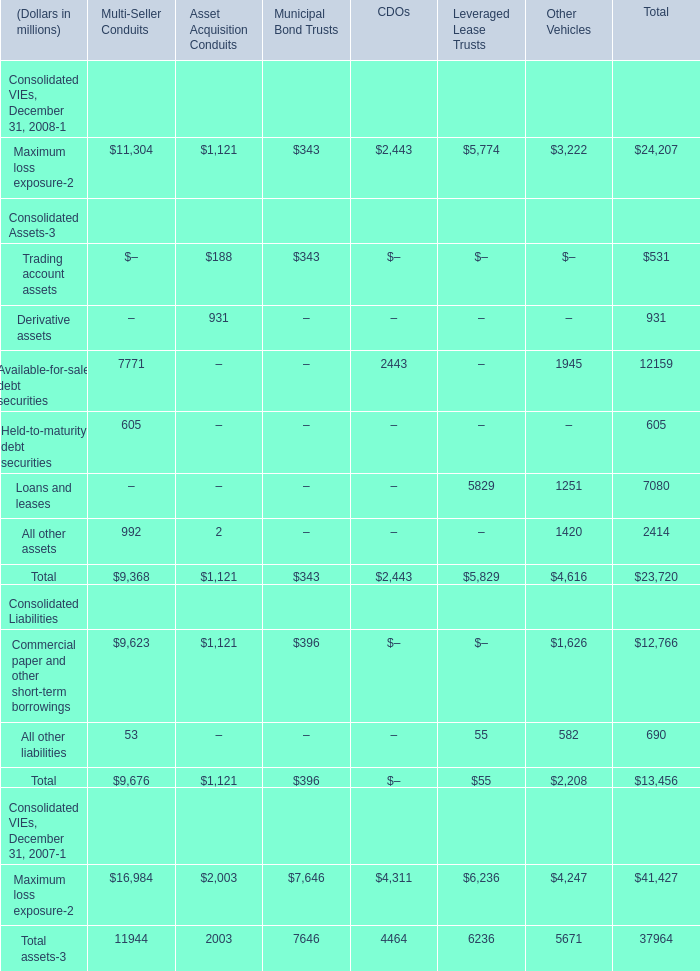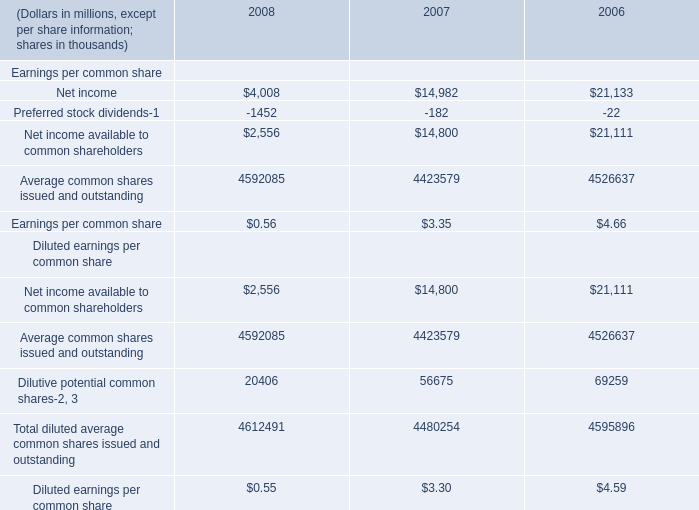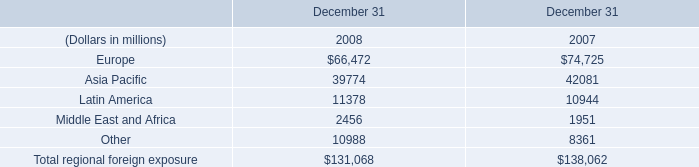what's the total amount of Europe of December 31 2008, and Average common shares issued and outstanding of 2008 ? 
Computations: (66472.0 + 4592085.0)
Answer: 4658557.0. 